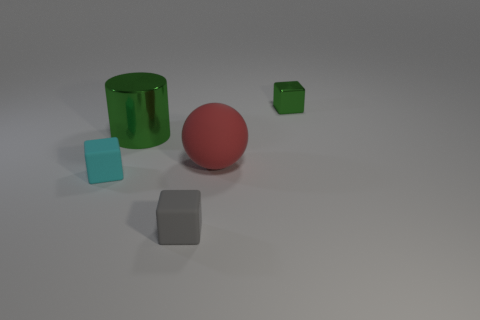Subtract all green shiny cubes. How many cubes are left? 2 Subtract all green blocks. How many blocks are left? 2 Add 3 big red balls. How many objects exist? 8 Subtract all cubes. How many objects are left? 2 Subtract 0 red cubes. How many objects are left? 5 Subtract 3 cubes. How many cubes are left? 0 Subtract all yellow blocks. Subtract all brown spheres. How many blocks are left? 3 Subtract all green shiny cylinders. Subtract all small gray rubber blocks. How many objects are left? 3 Add 2 red rubber objects. How many red rubber objects are left? 3 Add 3 big spheres. How many big spheres exist? 4 